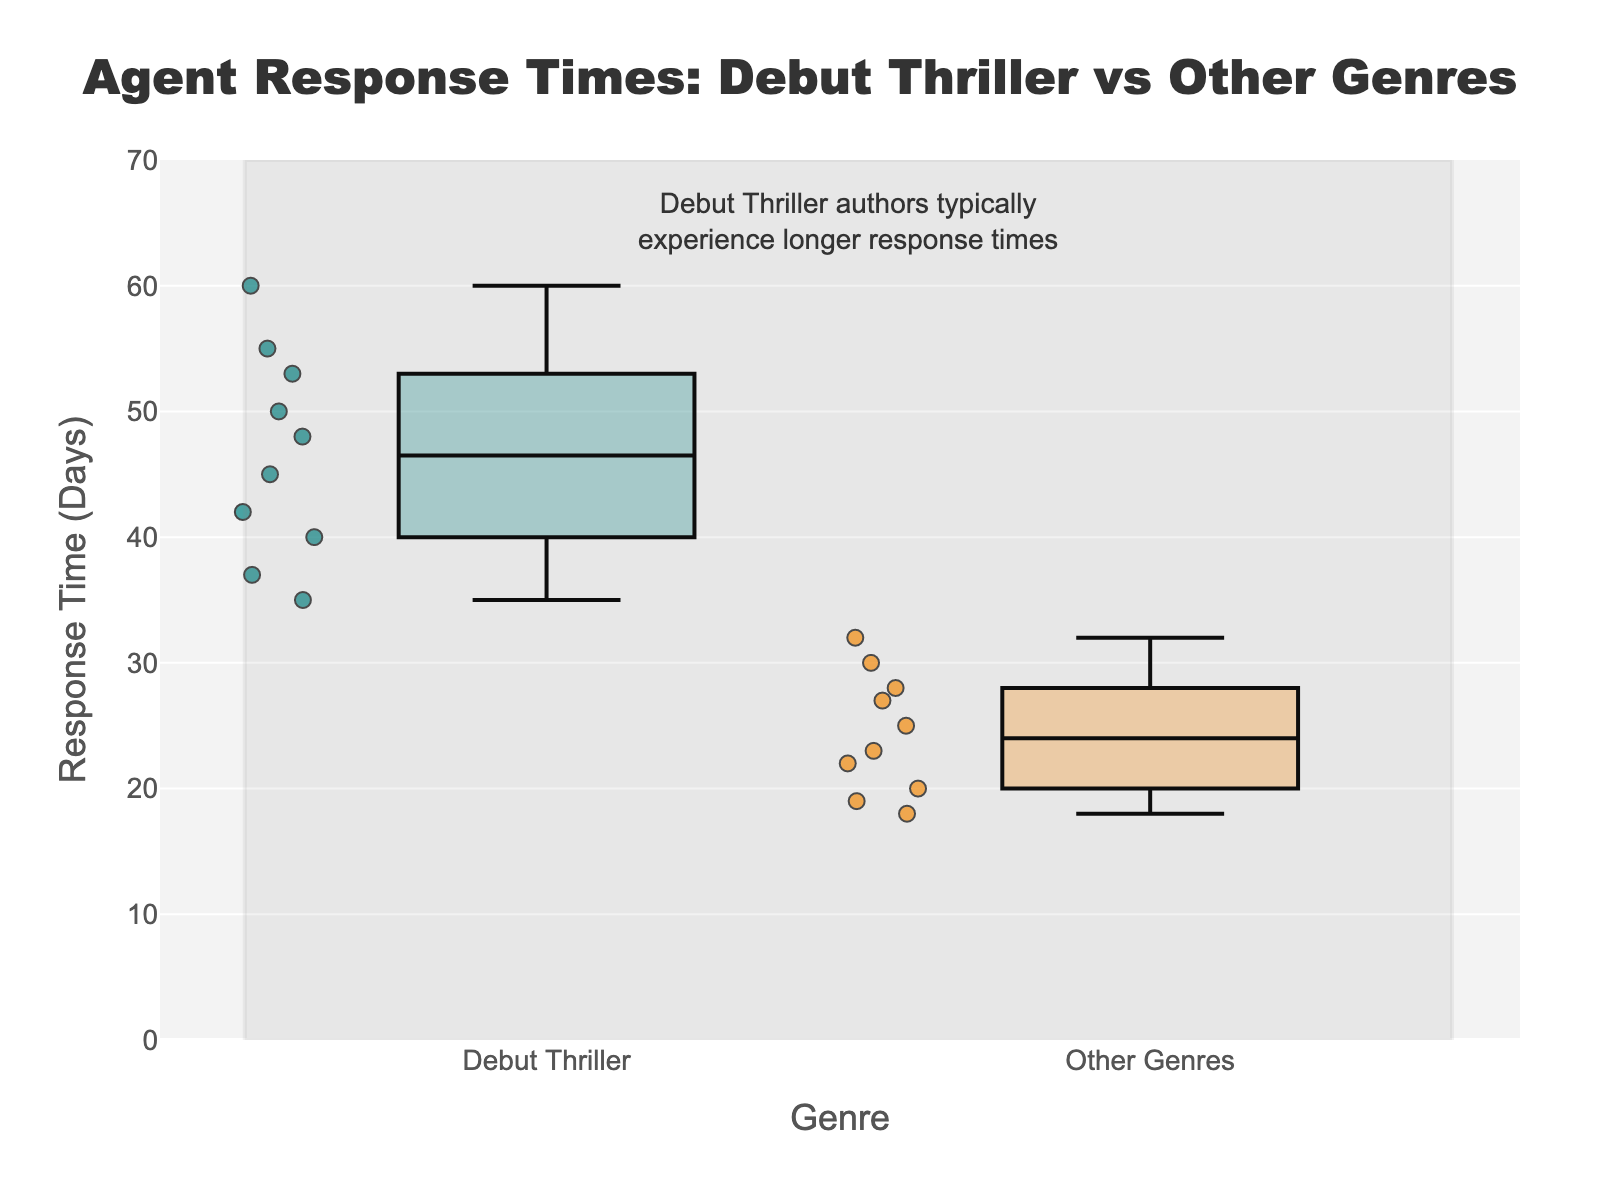What is the title of the figure? The title of the figure is usually located at the top center of the plot. In this case, the title is "Agent Response Times: Debut Thriller vs Other Genres".
Answer: Agent Response Times: Debut Thriller vs Other Genres What is the range of the y-axis? The y-axis represents the response time in days and is customized in the figure. The range shown on the y-axis goes from 0 to 70.
Answer: 0 to 70 What does the annotation at the top of the plot indicate? An annotation provides additional insights about the data visualized. In this plot, the annotation at the top indicates that debut thriller authors typically experience longer response times.
Answer: Debut thriller authors typically experience longer response times Which genre has more variability in response times? Variability in a box plot is indicated by the length of the box and the range of whiskers. The box and whiskers for the Debut Thriller group are more spread out than for Other Genres, indicating greater variability.
Answer: Debut Thriller What is the maximum response time in the "Debut Thriller" genre? To find the maximum response time for the Debut Thriller genre, look for the highest point in its box plot. This corresponds to Donald Maass with a response time of 60 days.
Answer: 60 days How does the median response time for "Debut Thriller" compare to "Other Genres"? The median in a box plot is represented by the line inside the box. By comparing these, "Debut Thriller" has a higher median response time compared to "Other Genres".
Answer: Debut Thriller has a higher median response time How many agents have response times below 30 days? To find this, count the individual points below 30 days on the box plots. All agents in "Other Genres" fall below 30 days except for Jim McCarthy (32). Therefore, it's 9 agents. In "Debut Thriller", no agents respond below 30 days.
Answer: 9 agents What are the colors used for the Debut Thriller and Other Genres groups? The colors can be identified from the boxes and their points. Debut Thriller is depicted in teal-like color while Other Genres is depicted in an orange-like color.
Answer: Teal and Orange What is the difference between the longest and shortest response times within "Other Genres"? To find the difference, subtract the shortest response time (18 days by Jennifer Jackson) from the longest response time (32 days by Jim McCarthy).
Answer: 14 days 